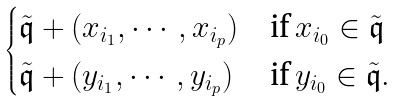Convert formula to latex. <formula><loc_0><loc_0><loc_500><loc_500>\begin{cases} \tilde { \mathfrak q } + ( x _ { i _ { 1 } } , \cdots , x _ { i _ { p } } ) & \text {if} \, x _ { i _ { 0 } } \in \tilde { \mathfrak q } \\ \tilde { \mathfrak q } + ( y _ { i _ { 1 } } , \cdots , y _ { i _ { p } } ) & \text {if} \, y _ { i _ { 0 } } \in \tilde { \mathfrak q } . \end{cases}</formula> 